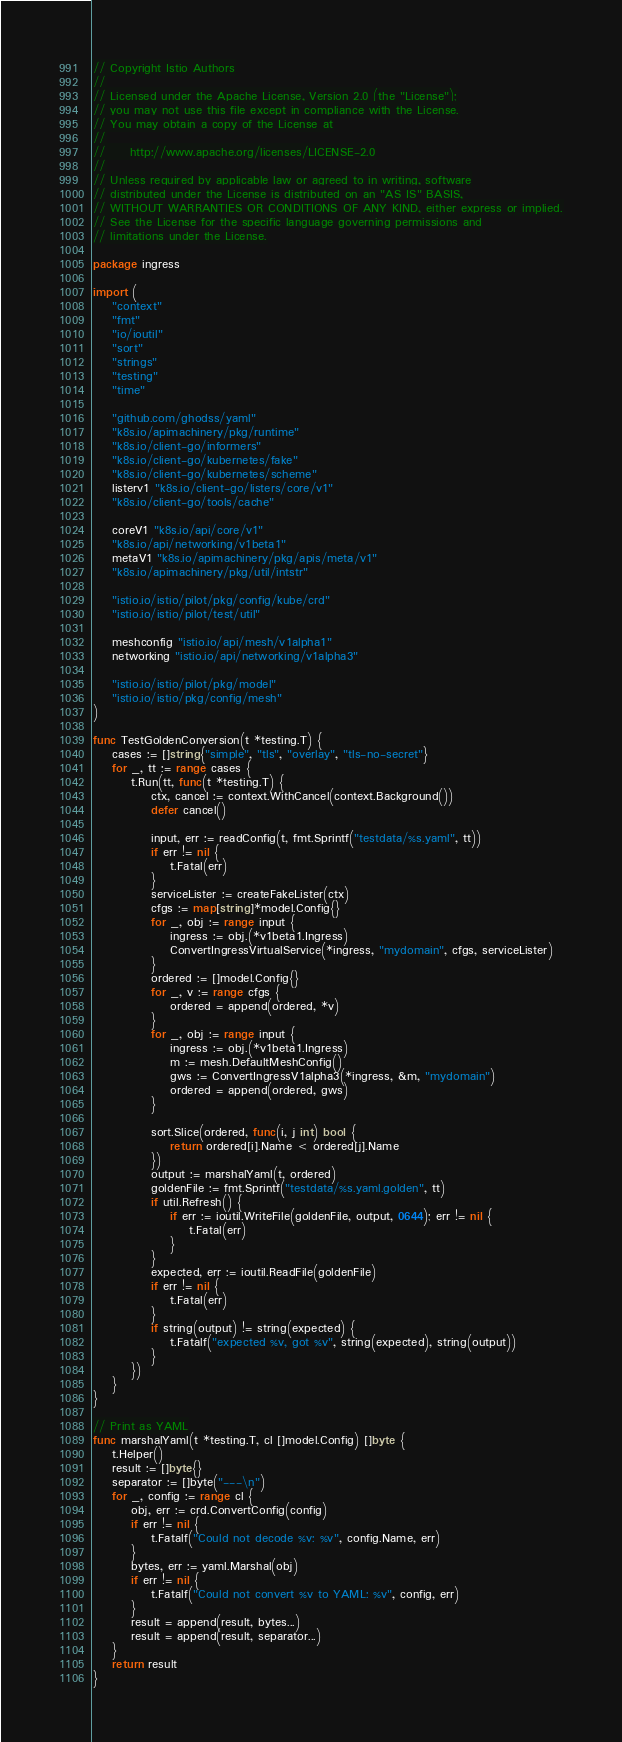<code> <loc_0><loc_0><loc_500><loc_500><_Go_>// Copyright Istio Authors
//
// Licensed under the Apache License, Version 2.0 (the "License");
// you may not use this file except in compliance with the License.
// You may obtain a copy of the License at
//
//     http://www.apache.org/licenses/LICENSE-2.0
//
// Unless required by applicable law or agreed to in writing, software
// distributed under the License is distributed on an "AS IS" BASIS,
// WITHOUT WARRANTIES OR CONDITIONS OF ANY KIND, either express or implied.
// See the License for the specific language governing permissions and
// limitations under the License.

package ingress

import (
	"context"
	"fmt"
	"io/ioutil"
	"sort"
	"strings"
	"testing"
	"time"

	"github.com/ghodss/yaml"
	"k8s.io/apimachinery/pkg/runtime"
	"k8s.io/client-go/informers"
	"k8s.io/client-go/kubernetes/fake"
	"k8s.io/client-go/kubernetes/scheme"
	listerv1 "k8s.io/client-go/listers/core/v1"
	"k8s.io/client-go/tools/cache"

	coreV1 "k8s.io/api/core/v1"
	"k8s.io/api/networking/v1beta1"
	metaV1 "k8s.io/apimachinery/pkg/apis/meta/v1"
	"k8s.io/apimachinery/pkg/util/intstr"

	"istio.io/istio/pilot/pkg/config/kube/crd"
	"istio.io/istio/pilot/test/util"

	meshconfig "istio.io/api/mesh/v1alpha1"
	networking "istio.io/api/networking/v1alpha3"

	"istio.io/istio/pilot/pkg/model"
	"istio.io/istio/pkg/config/mesh"
)

func TestGoldenConversion(t *testing.T) {
	cases := []string{"simple", "tls", "overlay", "tls-no-secret"}
	for _, tt := range cases {
		t.Run(tt, func(t *testing.T) {
			ctx, cancel := context.WithCancel(context.Background())
			defer cancel()

			input, err := readConfig(t, fmt.Sprintf("testdata/%s.yaml", tt))
			if err != nil {
				t.Fatal(err)
			}
			serviceLister := createFakeLister(ctx)
			cfgs := map[string]*model.Config{}
			for _, obj := range input {
				ingress := obj.(*v1beta1.Ingress)
				ConvertIngressVirtualService(*ingress, "mydomain", cfgs, serviceLister)
			}
			ordered := []model.Config{}
			for _, v := range cfgs {
				ordered = append(ordered, *v)
			}
			for _, obj := range input {
				ingress := obj.(*v1beta1.Ingress)
				m := mesh.DefaultMeshConfig()
				gws := ConvertIngressV1alpha3(*ingress, &m, "mydomain")
				ordered = append(ordered, gws)
			}

			sort.Slice(ordered, func(i, j int) bool {
				return ordered[i].Name < ordered[j].Name
			})
			output := marshalYaml(t, ordered)
			goldenFile := fmt.Sprintf("testdata/%s.yaml.golden", tt)
			if util.Refresh() {
				if err := ioutil.WriteFile(goldenFile, output, 0644); err != nil {
					t.Fatal(err)
				}
			}
			expected, err := ioutil.ReadFile(goldenFile)
			if err != nil {
				t.Fatal(err)
			}
			if string(output) != string(expected) {
				t.Fatalf("expected %v, got %v", string(expected), string(output))
			}
		})
	}
}

// Print as YAML
func marshalYaml(t *testing.T, cl []model.Config) []byte {
	t.Helper()
	result := []byte{}
	separator := []byte("---\n")
	for _, config := range cl {
		obj, err := crd.ConvertConfig(config)
		if err != nil {
			t.Fatalf("Could not decode %v: %v", config.Name, err)
		}
		bytes, err := yaml.Marshal(obj)
		if err != nil {
			t.Fatalf("Could not convert %v to YAML: %v", config, err)
		}
		result = append(result, bytes...)
		result = append(result, separator...)
	}
	return result
}
</code> 